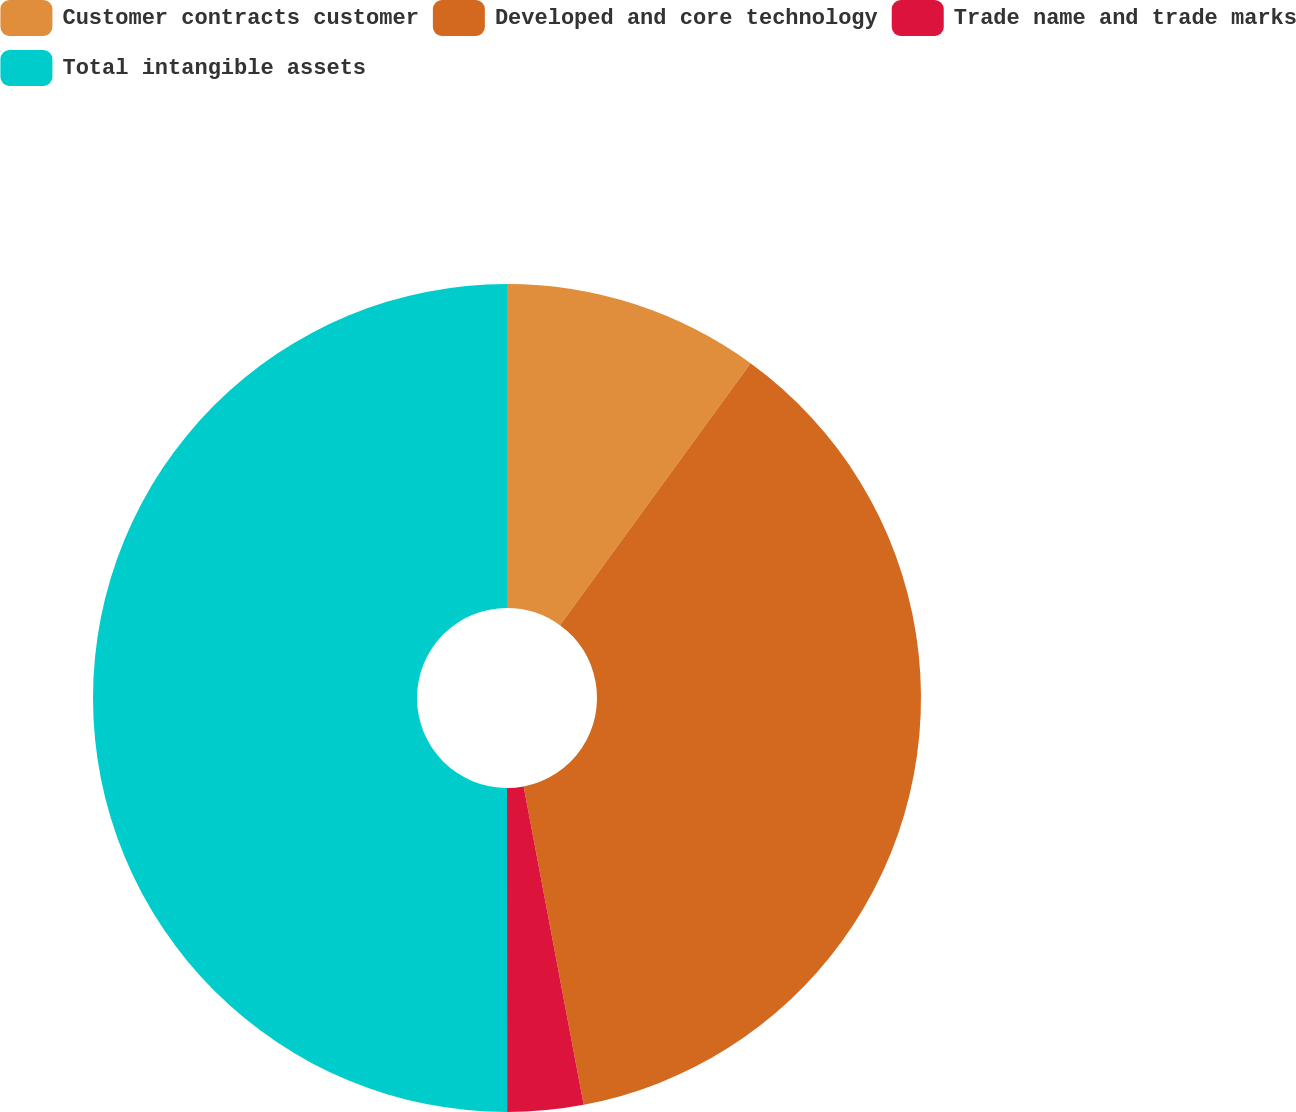Convert chart to OTSL. <chart><loc_0><loc_0><loc_500><loc_500><pie_chart><fcel>Customer contracts customer<fcel>Developed and core technology<fcel>Trade name and trade marks<fcel>Total intangible assets<nl><fcel>10.01%<fcel>37.02%<fcel>2.96%<fcel>50.0%<nl></chart> 